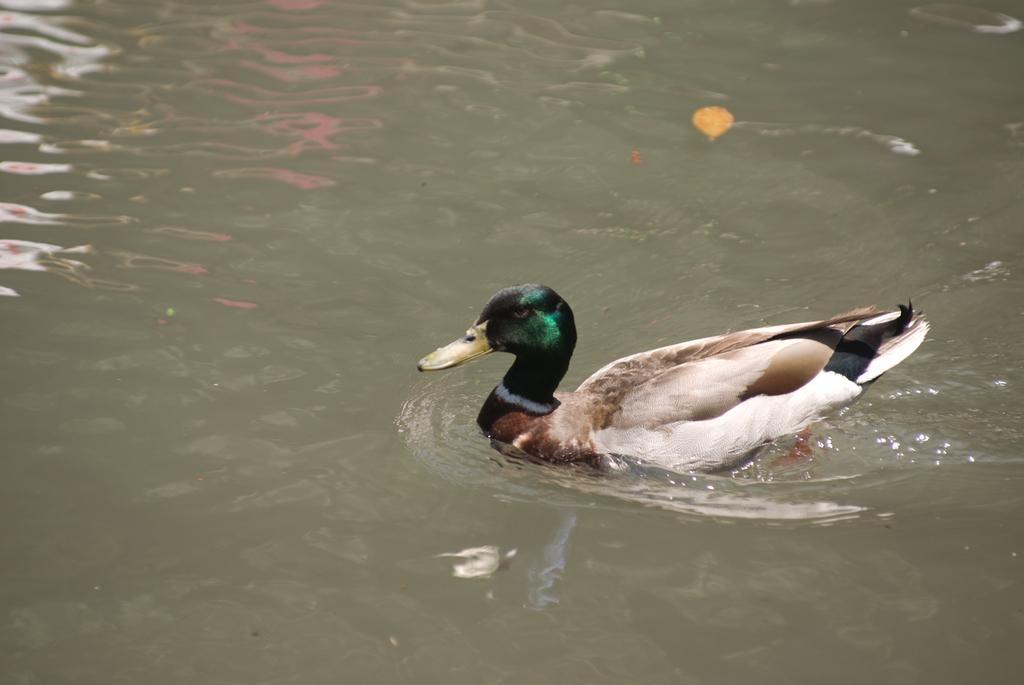How would you summarize this image in a sentence or two? In this image we can see a duck in the water. 